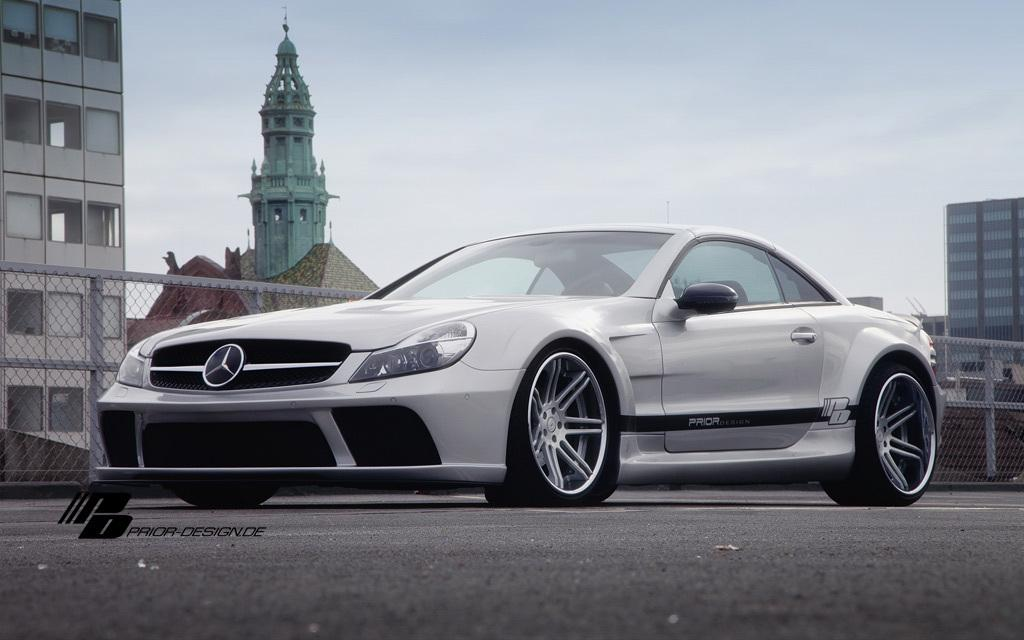What is the main subject of the image? There is a car in the image. What can be seen in the background of the image? There is mesh fencing, buildings, and the sky visible in the background of the image. Is there any indication of the image's origin or ownership? Yes, there is a watermark on the image. How does the car sort the pollution in the image? There is no indication of pollution in the image, and cars do not have the ability to sort pollution. What type of cork is used to seal the car's tires in the image? There is no mention of cork or tires in the image; it only features a car and the surrounding environment. 